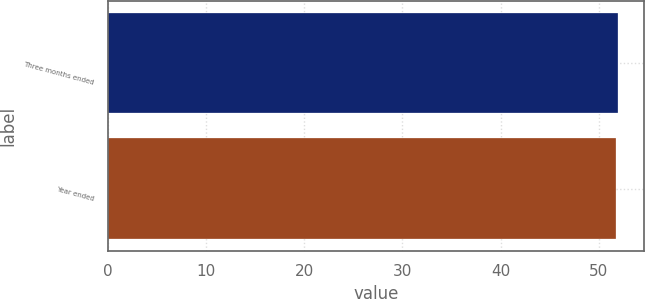Convert chart. <chart><loc_0><loc_0><loc_500><loc_500><bar_chart><fcel>Three months ended<fcel>Year ended<nl><fcel>52<fcel>51.8<nl></chart> 